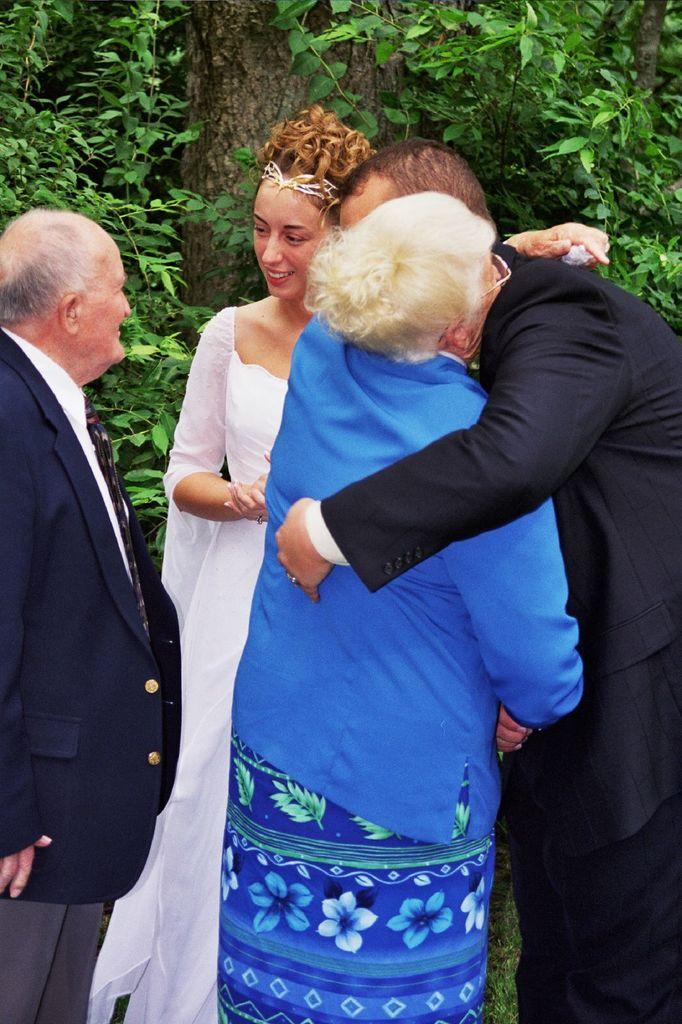How many people are present in the image? There are four persons standing in the image. Are any of the people interacting with each other? Yes, two of the persons are hugging each other. What can be seen in the background of the image? There are trees in the background of the image. What type of error message is displayed on the statement in the image? There is no statement or error message present in the image; it features four persons standing and interacting with each other. 